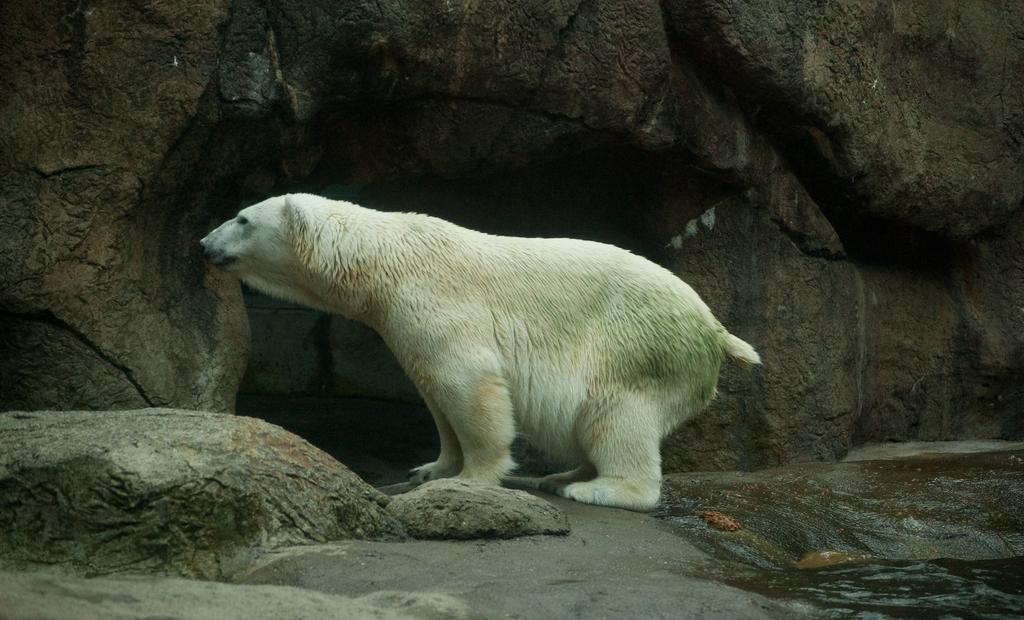What type of animal is in the image? There is a white polar bear in the image. What is visible in the background of the image? Water and rocks are visible in the image. What type of shelter can be seen in the image? There is a den in the image. What type of breakfast is the polar bear eating in the image? There is no breakfast present in the image; it only shows a polar bear, water, rocks, and a den. 